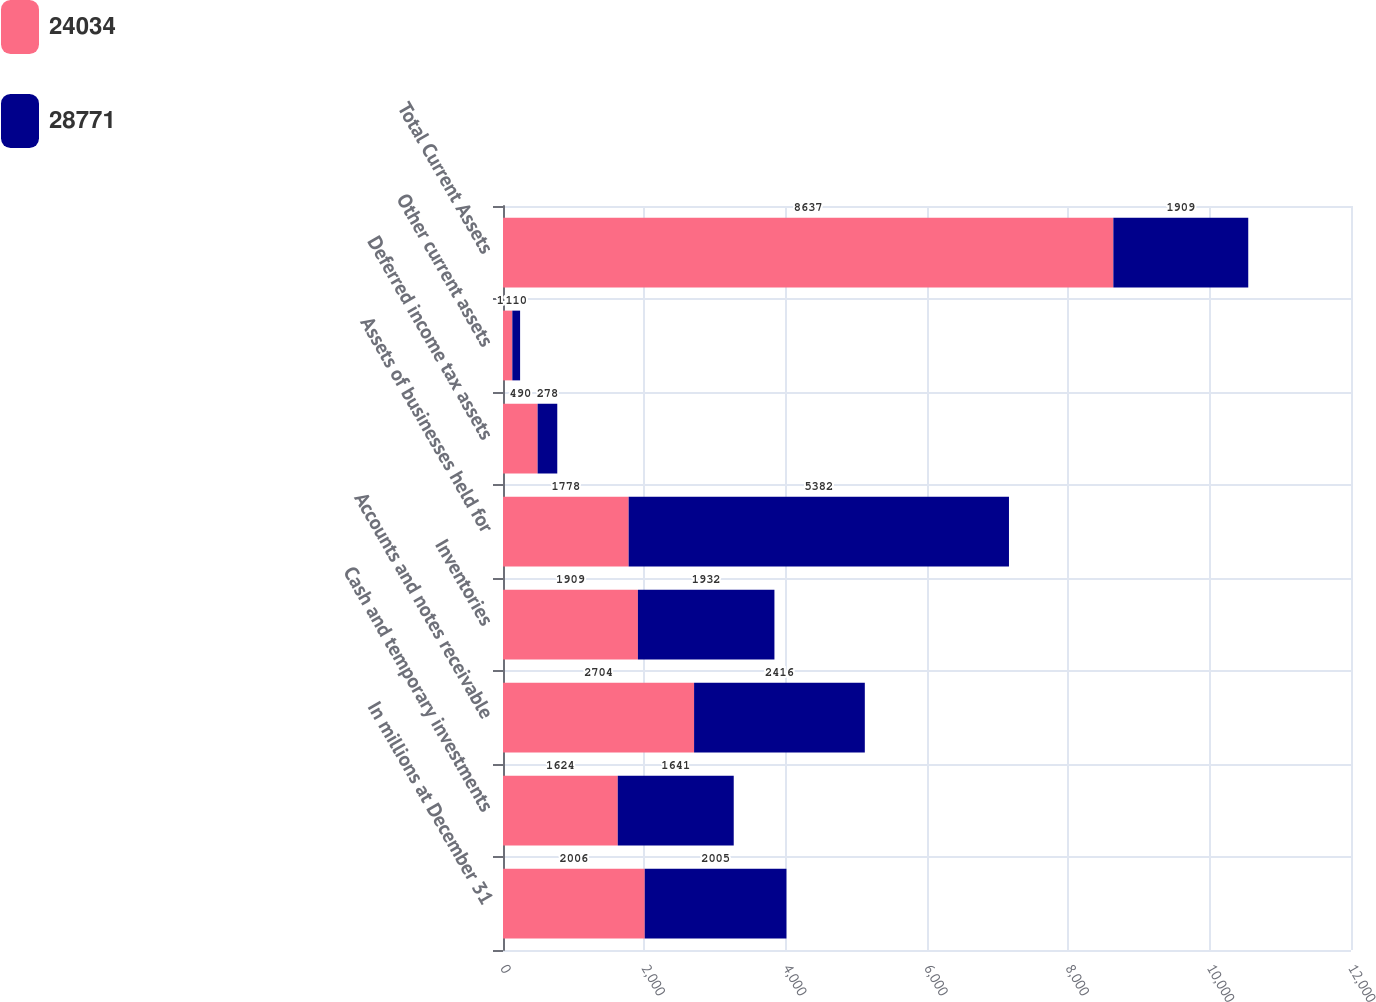Convert chart. <chart><loc_0><loc_0><loc_500><loc_500><stacked_bar_chart><ecel><fcel>In millions at December 31<fcel>Cash and temporary investments<fcel>Accounts and notes receivable<fcel>Inventories<fcel>Assets of businesses held for<fcel>Deferred income tax assets<fcel>Other current assets<fcel>Total Current Assets<nl><fcel>24034<fcel>2006<fcel>1624<fcel>2704<fcel>1909<fcel>1778<fcel>490<fcel>132<fcel>8637<nl><fcel>28771<fcel>2005<fcel>1641<fcel>2416<fcel>1932<fcel>5382<fcel>278<fcel>110<fcel>1909<nl></chart> 